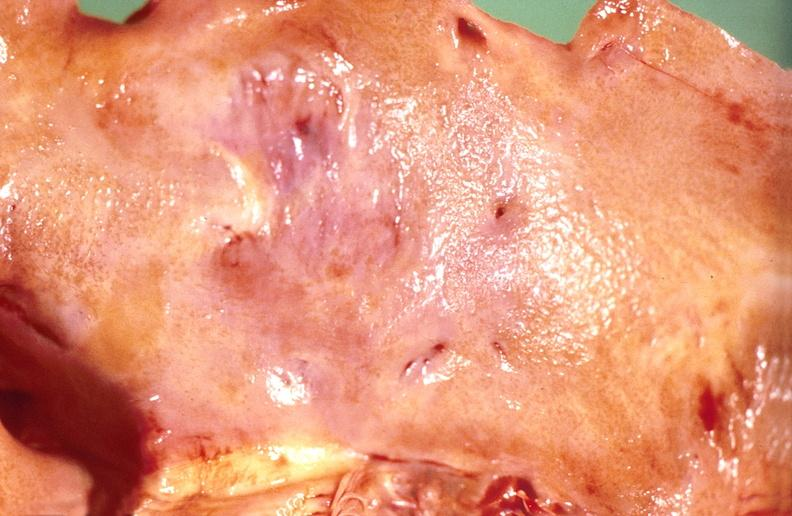what does this image show?
Answer the question using a single word or phrase. Amyloidosis 